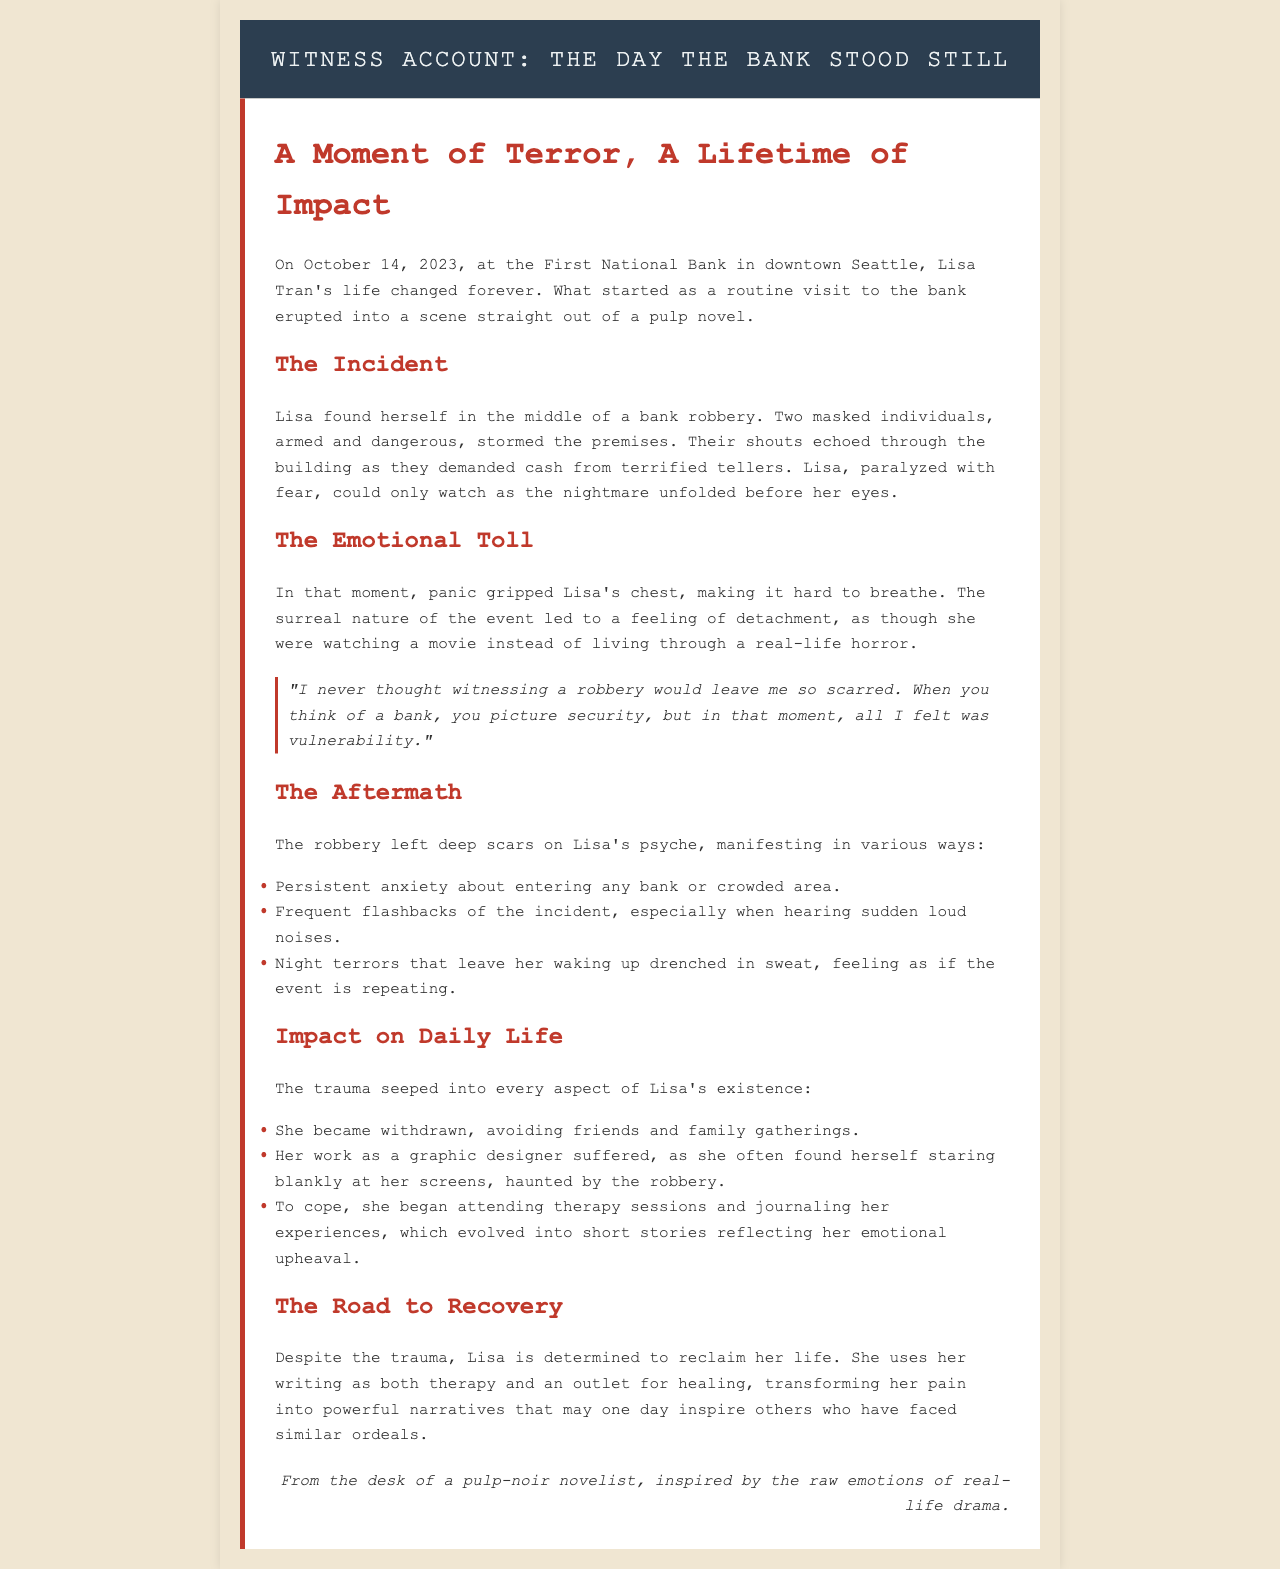What date did the bank robbery occur? The document explicitly states that the robbery took place on October 14, 2023.
Answer: October 14, 2023 Who is the witness in the account of the bank robbery? The document refers to the witness as Lisa Tran.
Answer: Lisa Tran What did Lisa experience during the bank robbery? The document describes Lisa as paralyzed with fear while watching the robbery unfold.
Answer: Paralyzed with fear What emotional state did Lisa feel during the incident? It is noted that panic gripped Lisa's chest, making it hard to breathe.
Answer: Panic List one of the psychological impacts on Lisa after the robbery. The document lists persistent anxiety about entering banks as one of the psychological impacts.
Answer: Persistent anxiety How did the incident affect Lisa's social life? The document states that Lisa became withdrawn, avoiding friends and family gatherings.
Answer: Withdrew socially What did Lisa do to cope with her trauma? Lisa began attending therapy sessions and journaling her experiences, seeking coping mechanisms.
Answer: Attending therapy sessions What does Lisa use her writing for? The document mentions that Lisa uses writing as both therapy and an outlet for healing.
Answer: Therapy and healing What metaphor is used to describe the bank before the robbery? The document mentions that when thinking of a bank, people picture security.
Answer: Security 